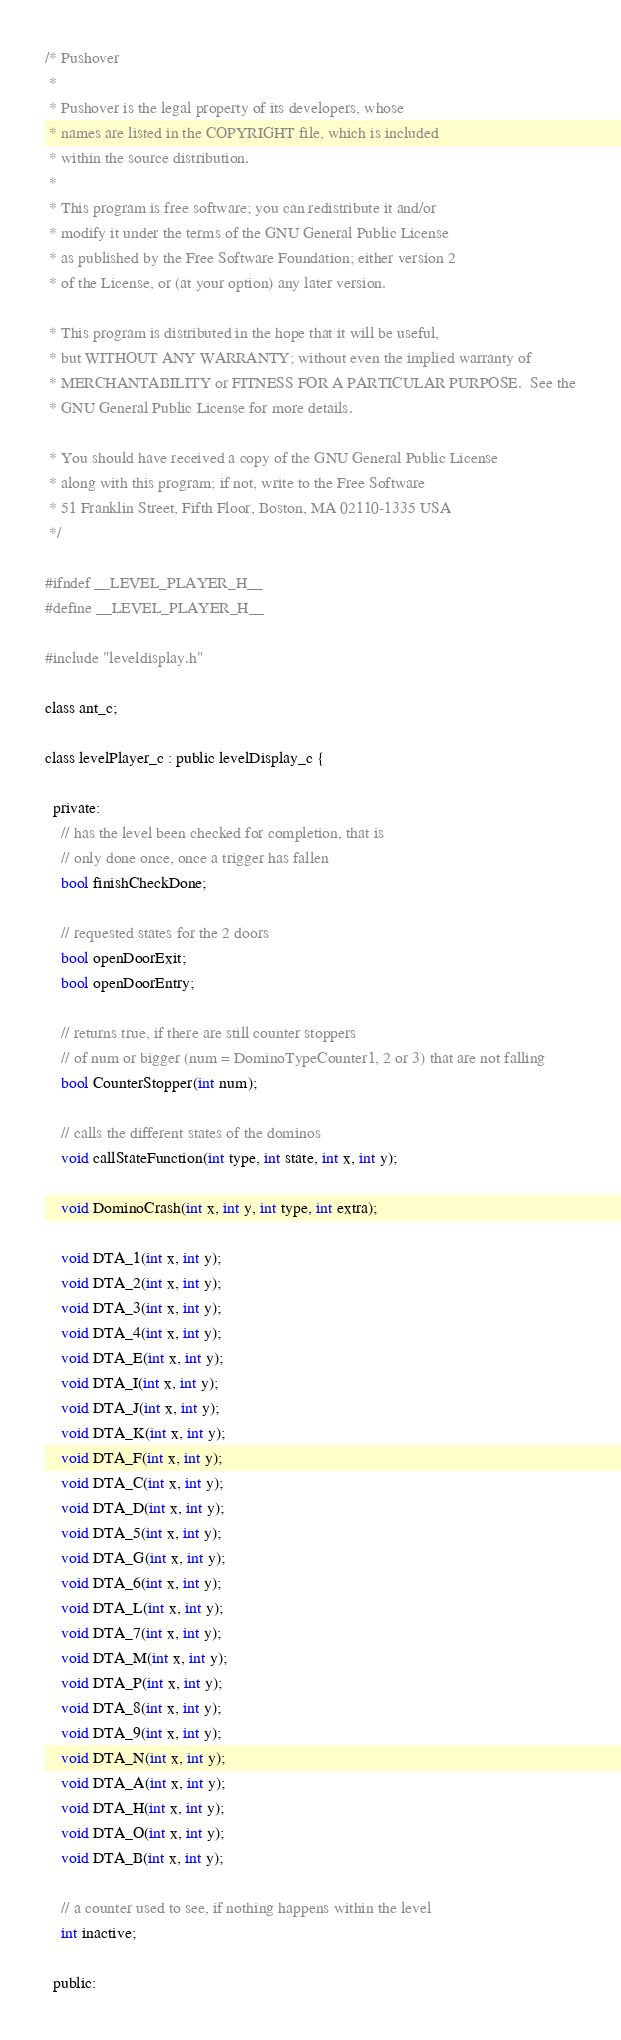<code> <loc_0><loc_0><loc_500><loc_500><_C_>/* Pushover
 *
 * Pushover is the legal property of its developers, whose
 * names are listed in the COPYRIGHT file, which is included
 * within the source distribution.
 *
 * This program is free software; you can redistribute it and/or
 * modify it under the terms of the GNU General Public License
 * as published by the Free Software Foundation; either version 2
 * of the License, or (at your option) any later version.

 * This program is distributed in the hope that it will be useful,
 * but WITHOUT ANY WARRANTY; without even the implied warranty of
 * MERCHANTABILITY or FITNESS FOR A PARTICULAR PURPOSE.  See the
 * GNU General Public License for more details.

 * You should have received a copy of the GNU General Public License
 * along with this program; if not, write to the Free Software
 * 51 Franklin Street, Fifth Floor, Boston, MA 02110-1335 USA
 */

#ifndef __LEVEL_PLAYER_H__
#define __LEVEL_PLAYER_H__

#include "leveldisplay.h"

class ant_c;

class levelPlayer_c : public levelDisplay_c {

  private:
    // has the level been checked for completion, that is
    // only done once, once a trigger has fallen
    bool finishCheckDone;

    // requested states for the 2 doors
    bool openDoorExit;
    bool openDoorEntry;

    // returns true, if there are still counter stoppers
    // of num or bigger (num = DominoTypeCounter1, 2 or 3) that are not falling
    bool CounterStopper(int num);

    // calls the different states of the dominos
    void callStateFunction(int type, int state, int x, int y);

    void DominoCrash(int x, int y, int type, int extra);

    void DTA_1(int x, int y);
    void DTA_2(int x, int y);
    void DTA_3(int x, int y);
    void DTA_4(int x, int y);
    void DTA_E(int x, int y);
    void DTA_I(int x, int y);
    void DTA_J(int x, int y);
    void DTA_K(int x, int y);
    void DTA_F(int x, int y);
    void DTA_C(int x, int y);
    void DTA_D(int x, int y);
    void DTA_5(int x, int y);
    void DTA_G(int x, int y);
    void DTA_6(int x, int y);
    void DTA_L(int x, int y);
    void DTA_7(int x, int y);
    void DTA_M(int x, int y);
    void DTA_P(int x, int y);
    void DTA_8(int x, int y);
    void DTA_9(int x, int y);
    void DTA_N(int x, int y);
    void DTA_A(int x, int y);
    void DTA_H(int x, int y);
    void DTA_O(int x, int y);
    void DTA_B(int x, int y);

    // a counter used to see, if nothing happens within the level
    int inactive;

  public:
</code> 